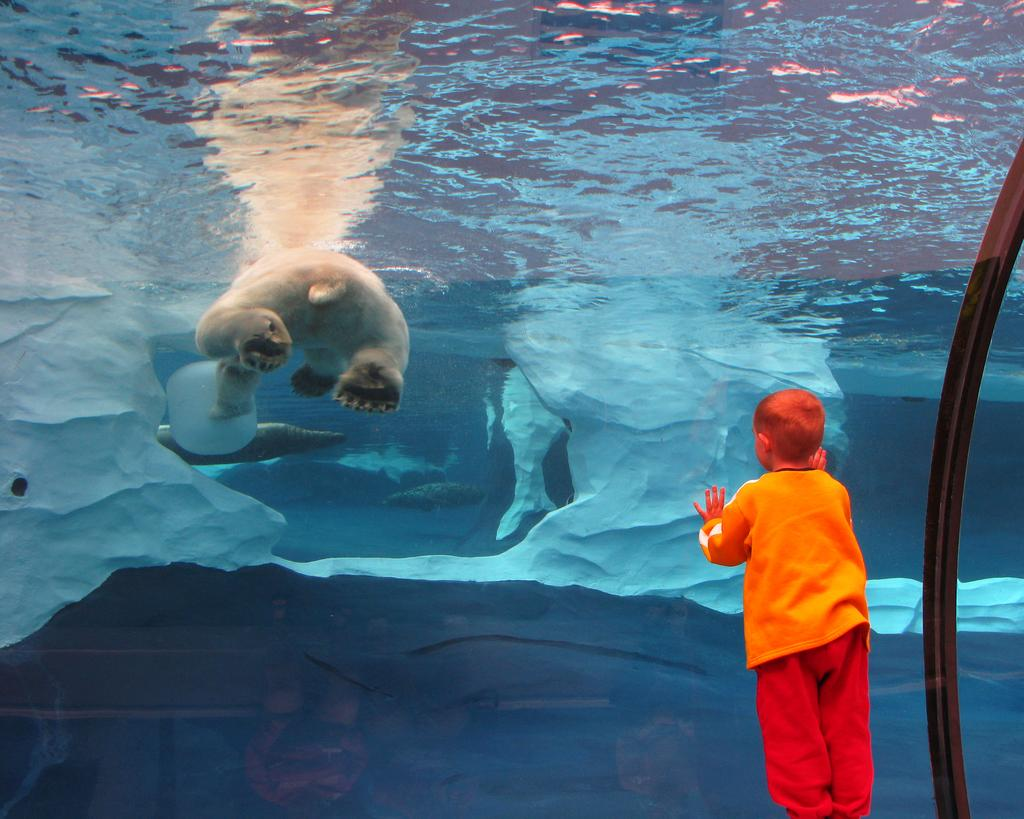What is the main subject of the image? There is a child in the image. What is the child wearing? The child is wearing an orange dress. Where is the child standing in relation to the glass door? The child is standing near a glass door. What can be seen through the glass door? Icebergs are visible through the glass door. What animal is floating in the water? A polar bear is floating in the water. What type of experience does the child have with sheep in the image? There are no sheep present in the image, so it cannot be determined if the child has any experience with them. 